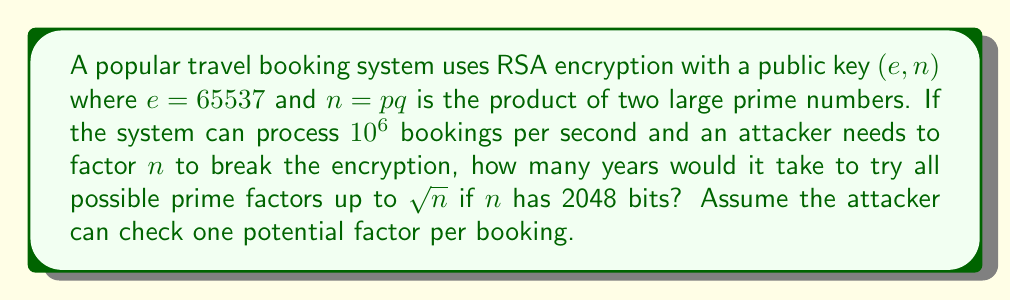Could you help me with this problem? Let's approach this step-by-step:

1) First, we need to calculate $\sqrt{n}$. Since $n$ has 2048 bits, it's approximately $2^{2048}$. Therefore, $\sqrt{n} \approx 2^{1024}$.

2) The number of prime numbers less than or equal to $x$ is approximately $\frac{x}{\ln(x)}$ (this is the prime number theorem).

3) So, the number of primes to check is approximately:

   $$\frac{2^{1024}}{\ln(2^{1024})} = \frac{2^{1024}}{1024 \ln(2)}$$

4) The attacker can check one potential factor per booking, and there are $10^6$ bookings per second. So, the number of factors that can be checked per second is $10^6$.

5) The time required in seconds is:

   $$\frac{2^{1024}}{1024 \ln(2) \cdot 10^6}$$

6) To convert this to years, we divide by the number of seconds in a year (approximately $31536000 = 365 \cdot 24 \cdot 60 \cdot 60$):

   $$\frac{2^{1024}}{1024 \ln(2) \cdot 10^6 \cdot 31536000}$$

7) Calculating this (you may need a powerful calculator):

   $$\approx 1.23 \cdot 10^{292} \text{ years}$$

This is an astronomically large number, far exceeding the age of the universe, demonstrating the strength of RSA encryption with large key sizes.
Answer: $1.23 \cdot 10^{292}$ years 